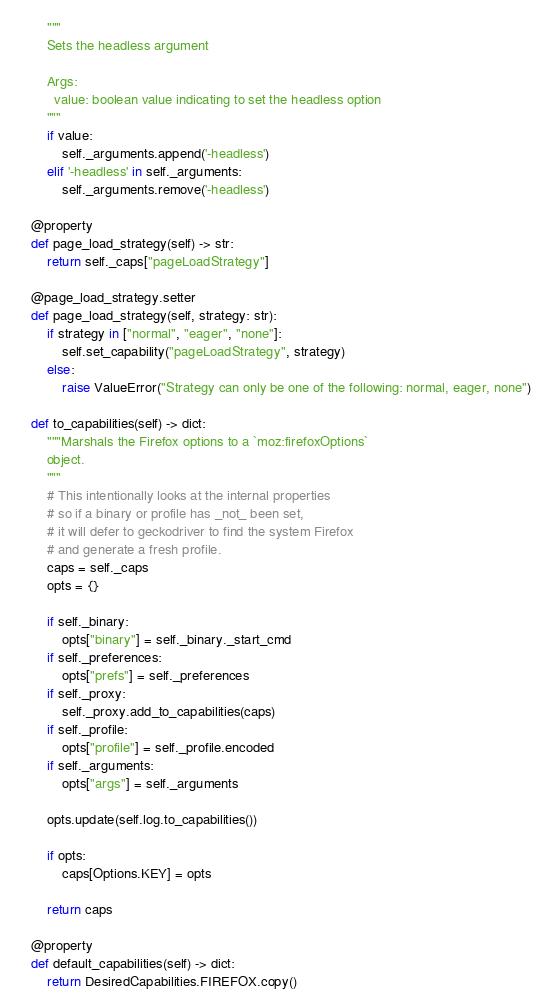Convert code to text. <code><loc_0><loc_0><loc_500><loc_500><_Python_>        """
        Sets the headless argument

        Args:
          value: boolean value indicating to set the headless option
        """
        if value:
            self._arguments.append('-headless')
        elif '-headless' in self._arguments:
            self._arguments.remove('-headless')

    @property
    def page_load_strategy(self) -> str:
        return self._caps["pageLoadStrategy"]

    @page_load_strategy.setter
    def page_load_strategy(self, strategy: str):
        if strategy in ["normal", "eager", "none"]:
            self.set_capability("pageLoadStrategy", strategy)
        else:
            raise ValueError("Strategy can only be one of the following: normal, eager, none")

    def to_capabilities(self) -> dict:
        """Marshals the Firefox options to a `moz:firefoxOptions`
        object.
        """
        # This intentionally looks at the internal properties
        # so if a binary or profile has _not_ been set,
        # it will defer to geckodriver to find the system Firefox
        # and generate a fresh profile.
        caps = self._caps
        opts = {}

        if self._binary:
            opts["binary"] = self._binary._start_cmd
        if self._preferences:
            opts["prefs"] = self._preferences
        if self._proxy:
            self._proxy.add_to_capabilities(caps)
        if self._profile:
            opts["profile"] = self._profile.encoded
        if self._arguments:
            opts["args"] = self._arguments

        opts.update(self.log.to_capabilities())

        if opts:
            caps[Options.KEY] = opts

        return caps

    @property
    def default_capabilities(self) -> dict:
        return DesiredCapabilities.FIREFOX.copy()
</code> 